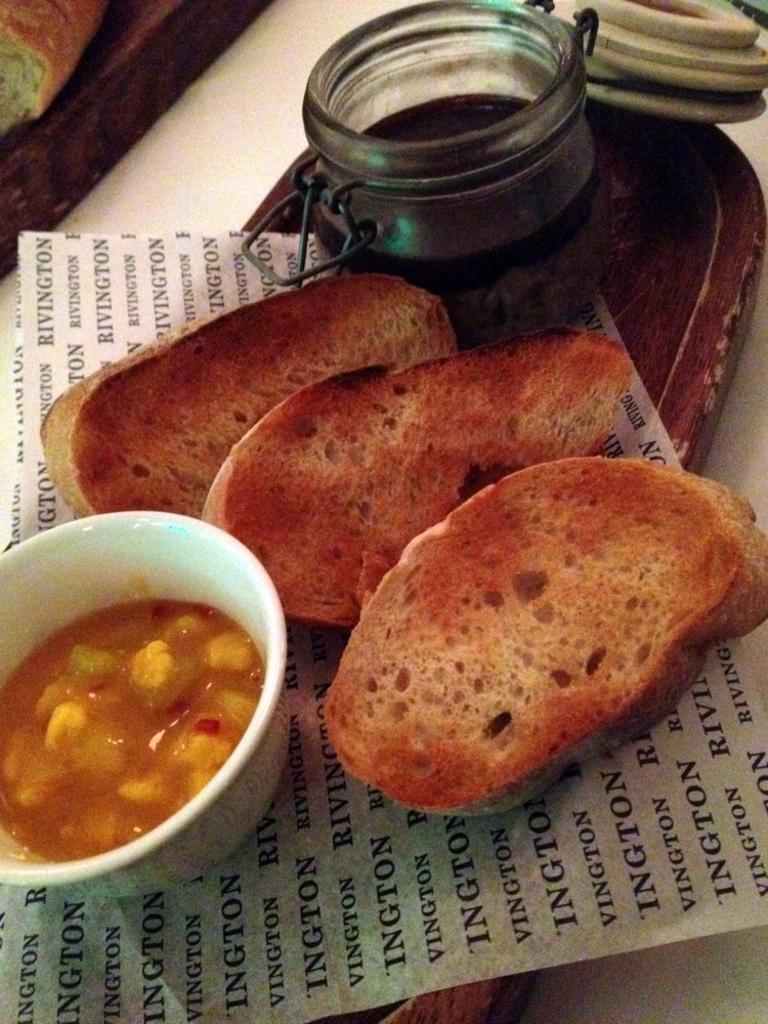Could you give a brief overview of what you see in this image? In this image there is a table, on that table there is a plate , in that place there are some food items and a paper. 